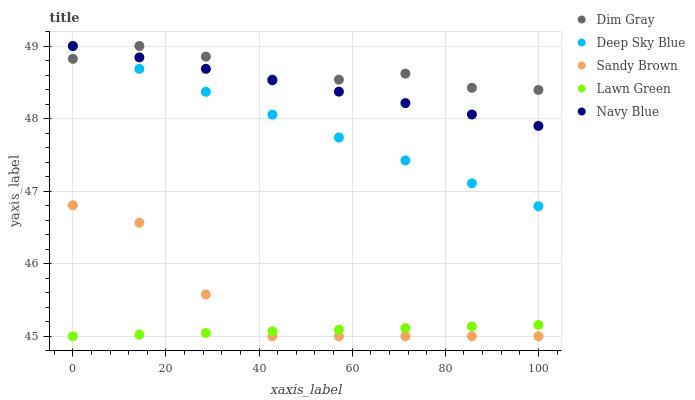Does Lawn Green have the minimum area under the curve?
Answer yes or no. Yes. Does Dim Gray have the maximum area under the curve?
Answer yes or no. Yes. Does Sandy Brown have the minimum area under the curve?
Answer yes or no. No. Does Sandy Brown have the maximum area under the curve?
Answer yes or no. No. Is Lawn Green the smoothest?
Answer yes or no. Yes. Is Sandy Brown the roughest?
Answer yes or no. Yes. Is Dim Gray the smoothest?
Answer yes or no. No. Is Dim Gray the roughest?
Answer yes or no. No. Does Lawn Green have the lowest value?
Answer yes or no. Yes. Does Dim Gray have the lowest value?
Answer yes or no. No. Does Navy Blue have the highest value?
Answer yes or no. Yes. Does Sandy Brown have the highest value?
Answer yes or no. No. Is Sandy Brown less than Navy Blue?
Answer yes or no. Yes. Is Navy Blue greater than Sandy Brown?
Answer yes or no. Yes. Does Deep Sky Blue intersect Navy Blue?
Answer yes or no. Yes. Is Deep Sky Blue less than Navy Blue?
Answer yes or no. No. Is Deep Sky Blue greater than Navy Blue?
Answer yes or no. No. Does Sandy Brown intersect Navy Blue?
Answer yes or no. No. 